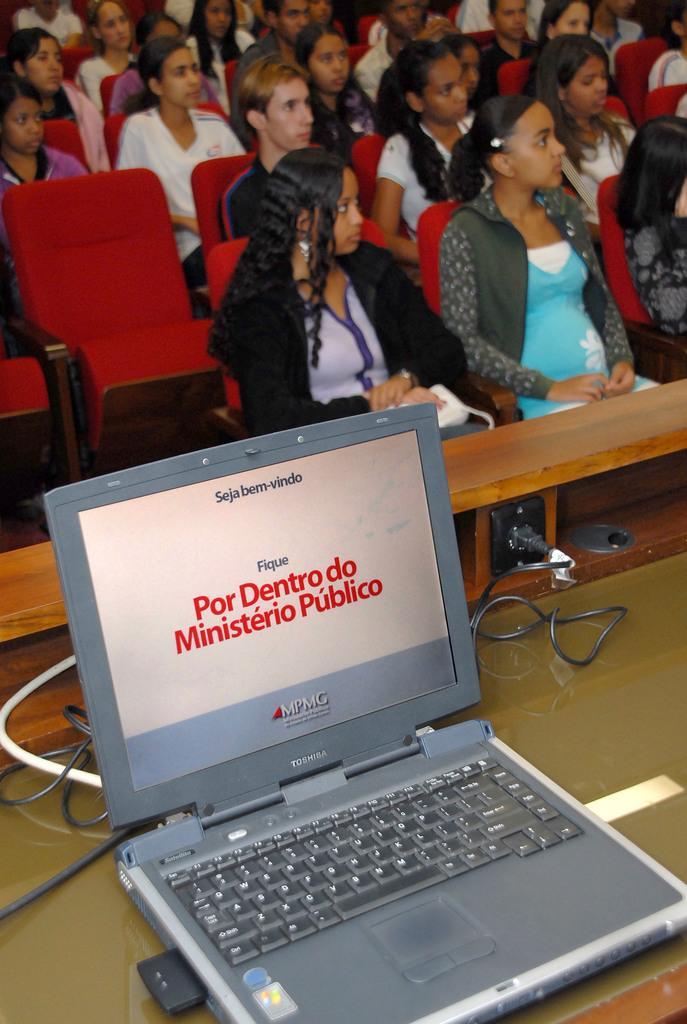In one or two sentences, can you explain what this image depicts? It is look like a auditorium. So many peoples are sat on the red color chairs. In the bottom, we can see laptop, screen, wire, switch board and a table. 